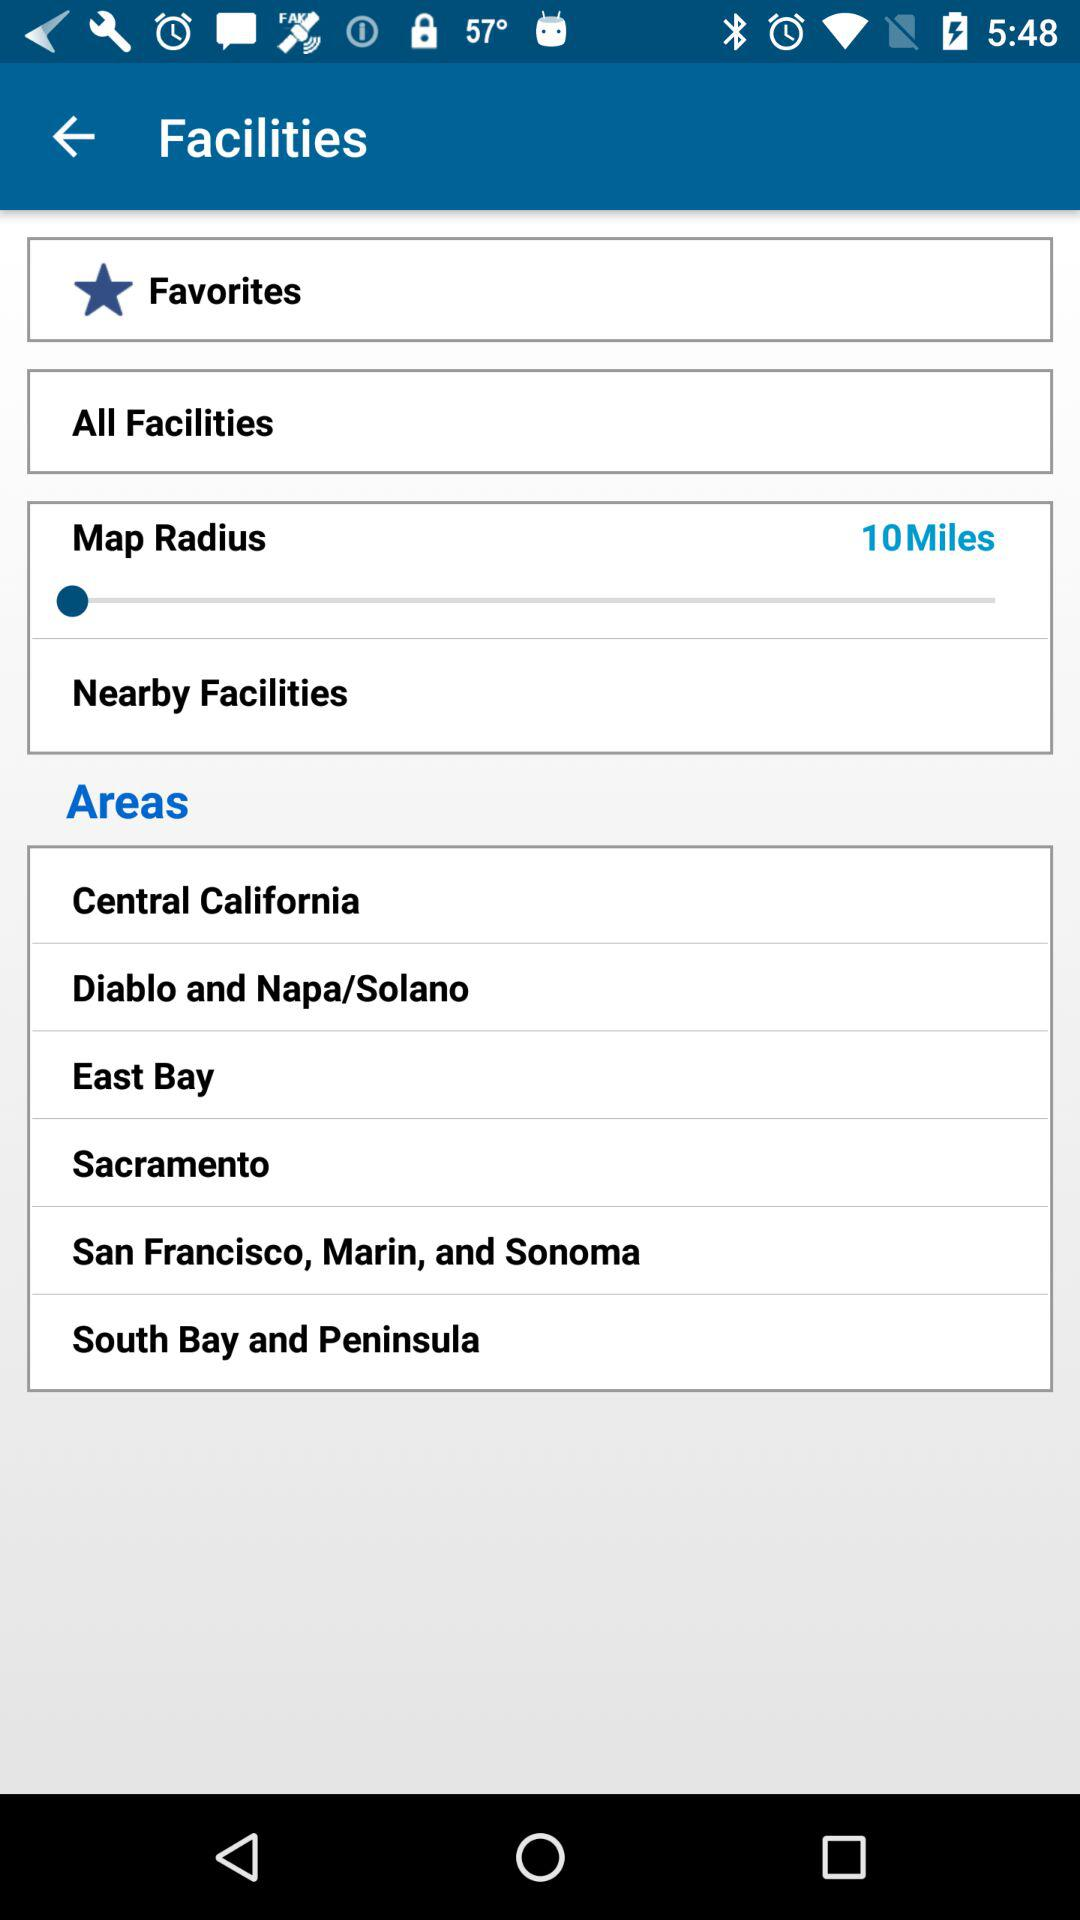What is the map radius? The map radius is 10 miles. 